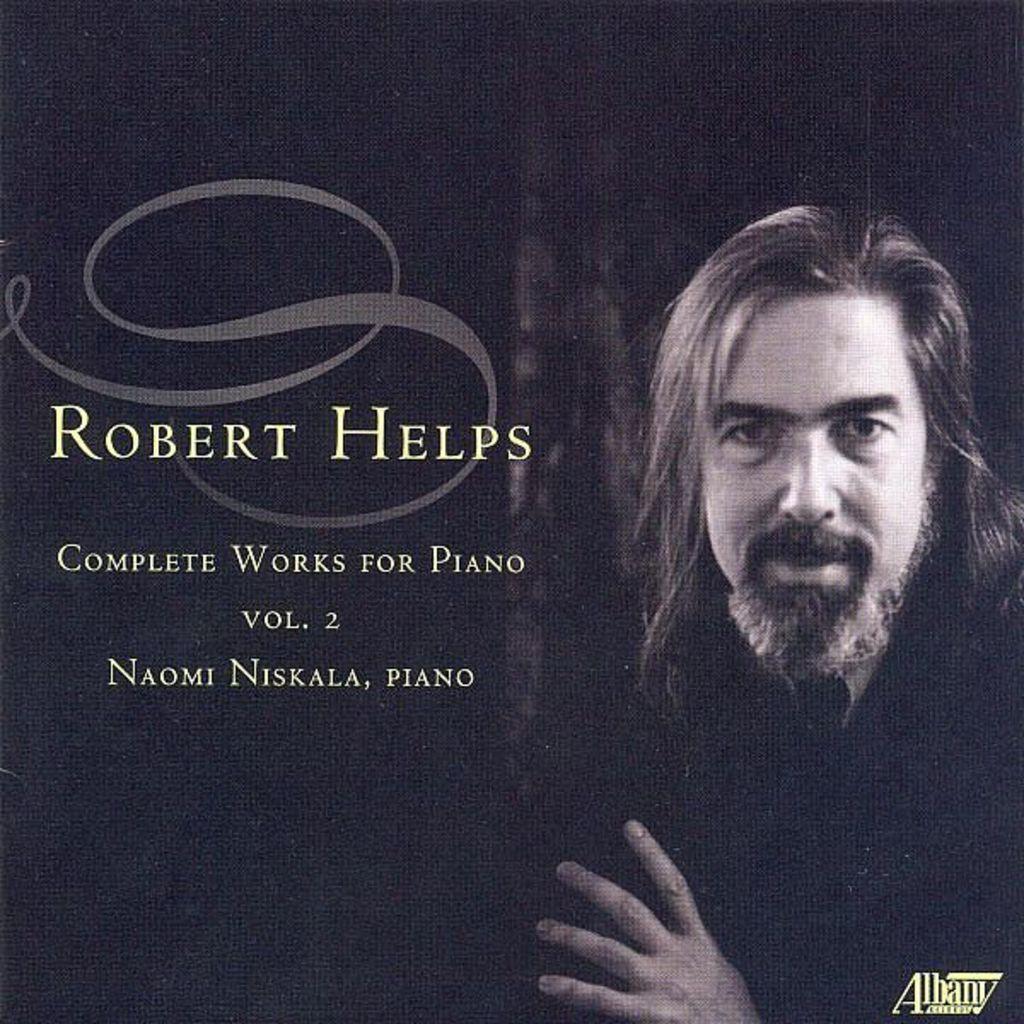Describe this image in one or two sentences. In this image on the right side there is one person, and on the left side there is some text. 